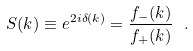<formula> <loc_0><loc_0><loc_500><loc_500>S ( k ) \equiv e ^ { 2 i \delta ( k ) } = \frac { f _ { - } ( k ) } { f _ { + } ( k ) } \ .</formula> 